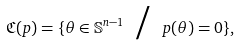<formula> <loc_0><loc_0><loc_500><loc_500>\mathfrak { C } ( p ) = \{ \theta \in \mathbb { S } ^ { n - 1 } \text { / } p ( \theta ) = 0 \} ,</formula> 